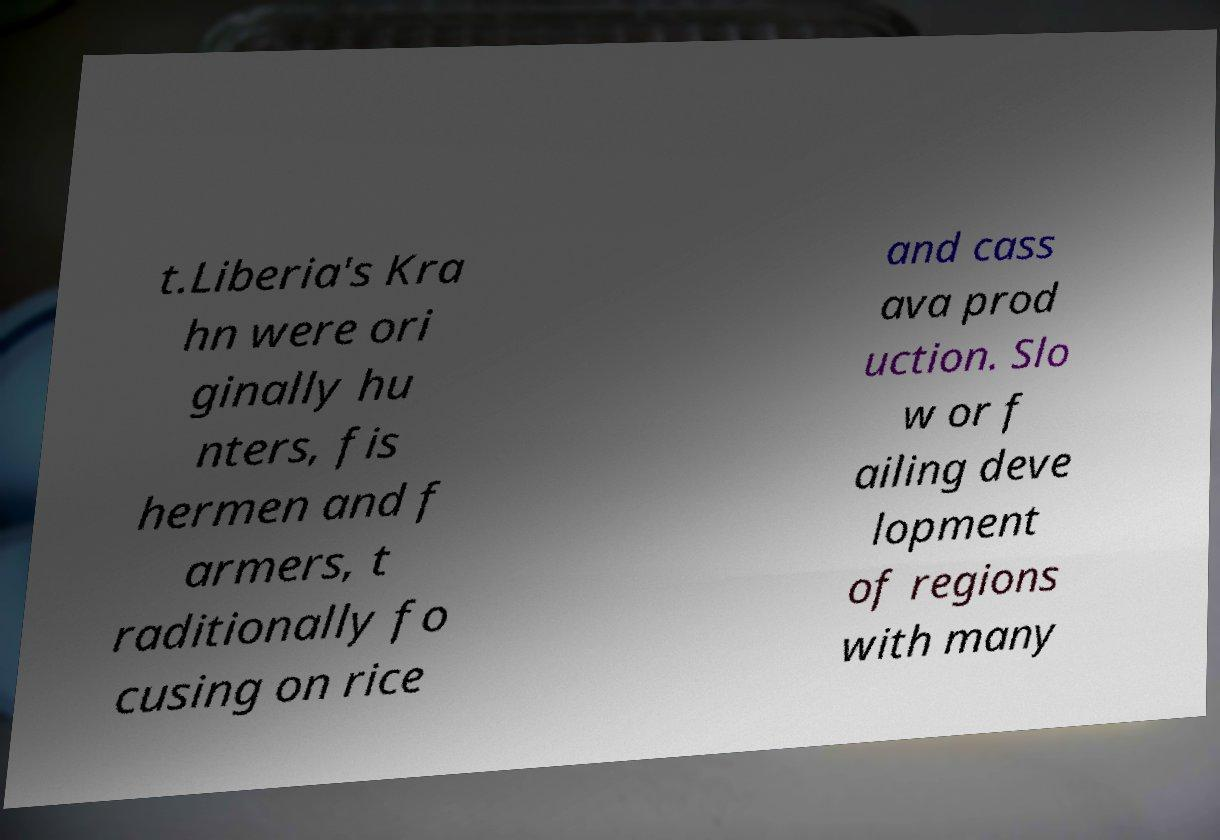There's text embedded in this image that I need extracted. Can you transcribe it verbatim? t.Liberia's Kra hn were ori ginally hu nters, fis hermen and f armers, t raditionally fo cusing on rice and cass ava prod uction. Slo w or f ailing deve lopment of regions with many 